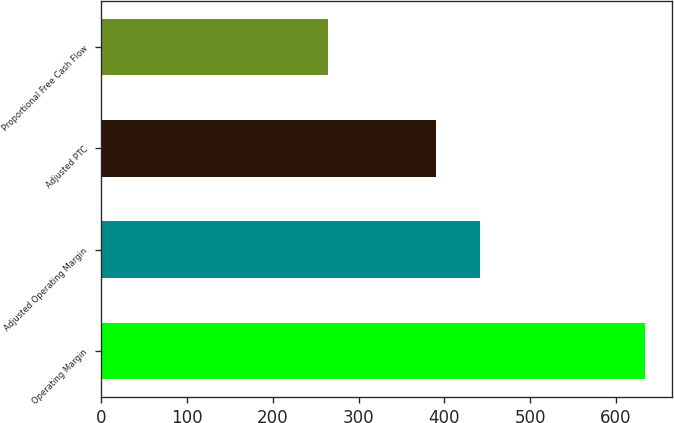Convert chart. <chart><loc_0><loc_0><loc_500><loc_500><bar_chart><fcel>Operating Margin<fcel>Adjusted Operating Margin<fcel>Adjusted PTC<fcel>Proportional Free Cash Flow<nl><fcel>634<fcel>442<fcel>390<fcel>264<nl></chart> 